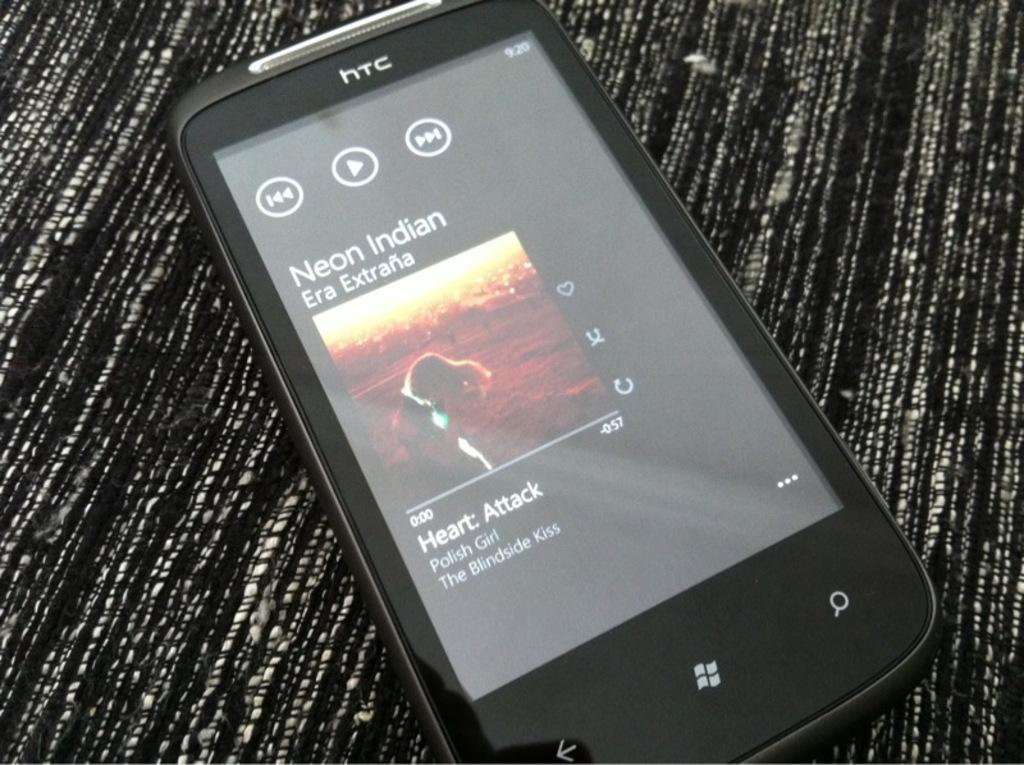<image>
Summarize the visual content of the image. An HTC phone is playing a Neon Indian track. 